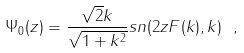<formula> <loc_0><loc_0><loc_500><loc_500>\Psi _ { 0 } ( z ) = { \frac { \sqrt { 2 } k } { \sqrt { 1 + k ^ { 2 } } } } s n ( 2 z F ( k ) , k ) \ ,</formula> 